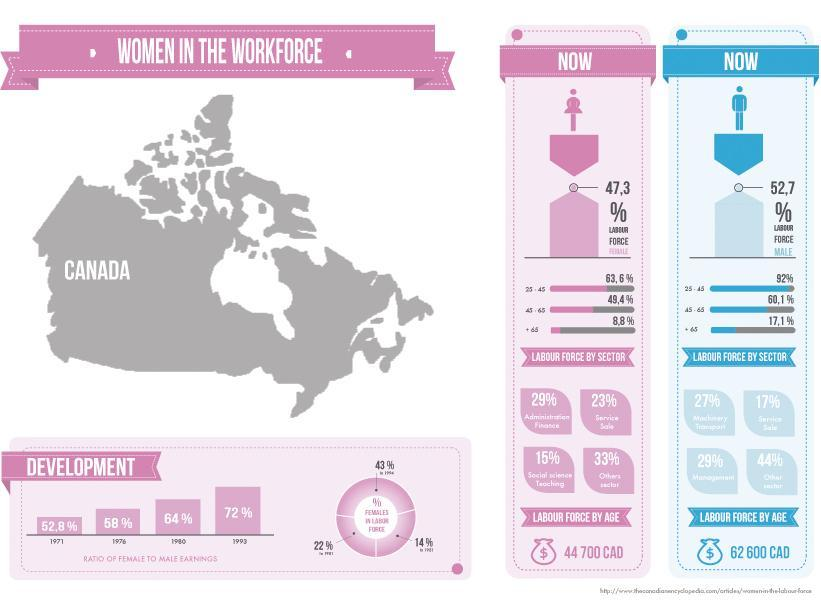What percent of the women aged 45-65 years are in the labour force of Canada?
Answer the question with a short phrase. 49,4% What is the percentage ratio of female to male earnings in Canada in 1993? 72% What percentage of women are in the labour force of Canada? 47.3% What percent of the men aged above 65 years are in the labour force of Canada? 17,1% What is the percentage ratio of female to male earnings in Canada in 1976? 58% 